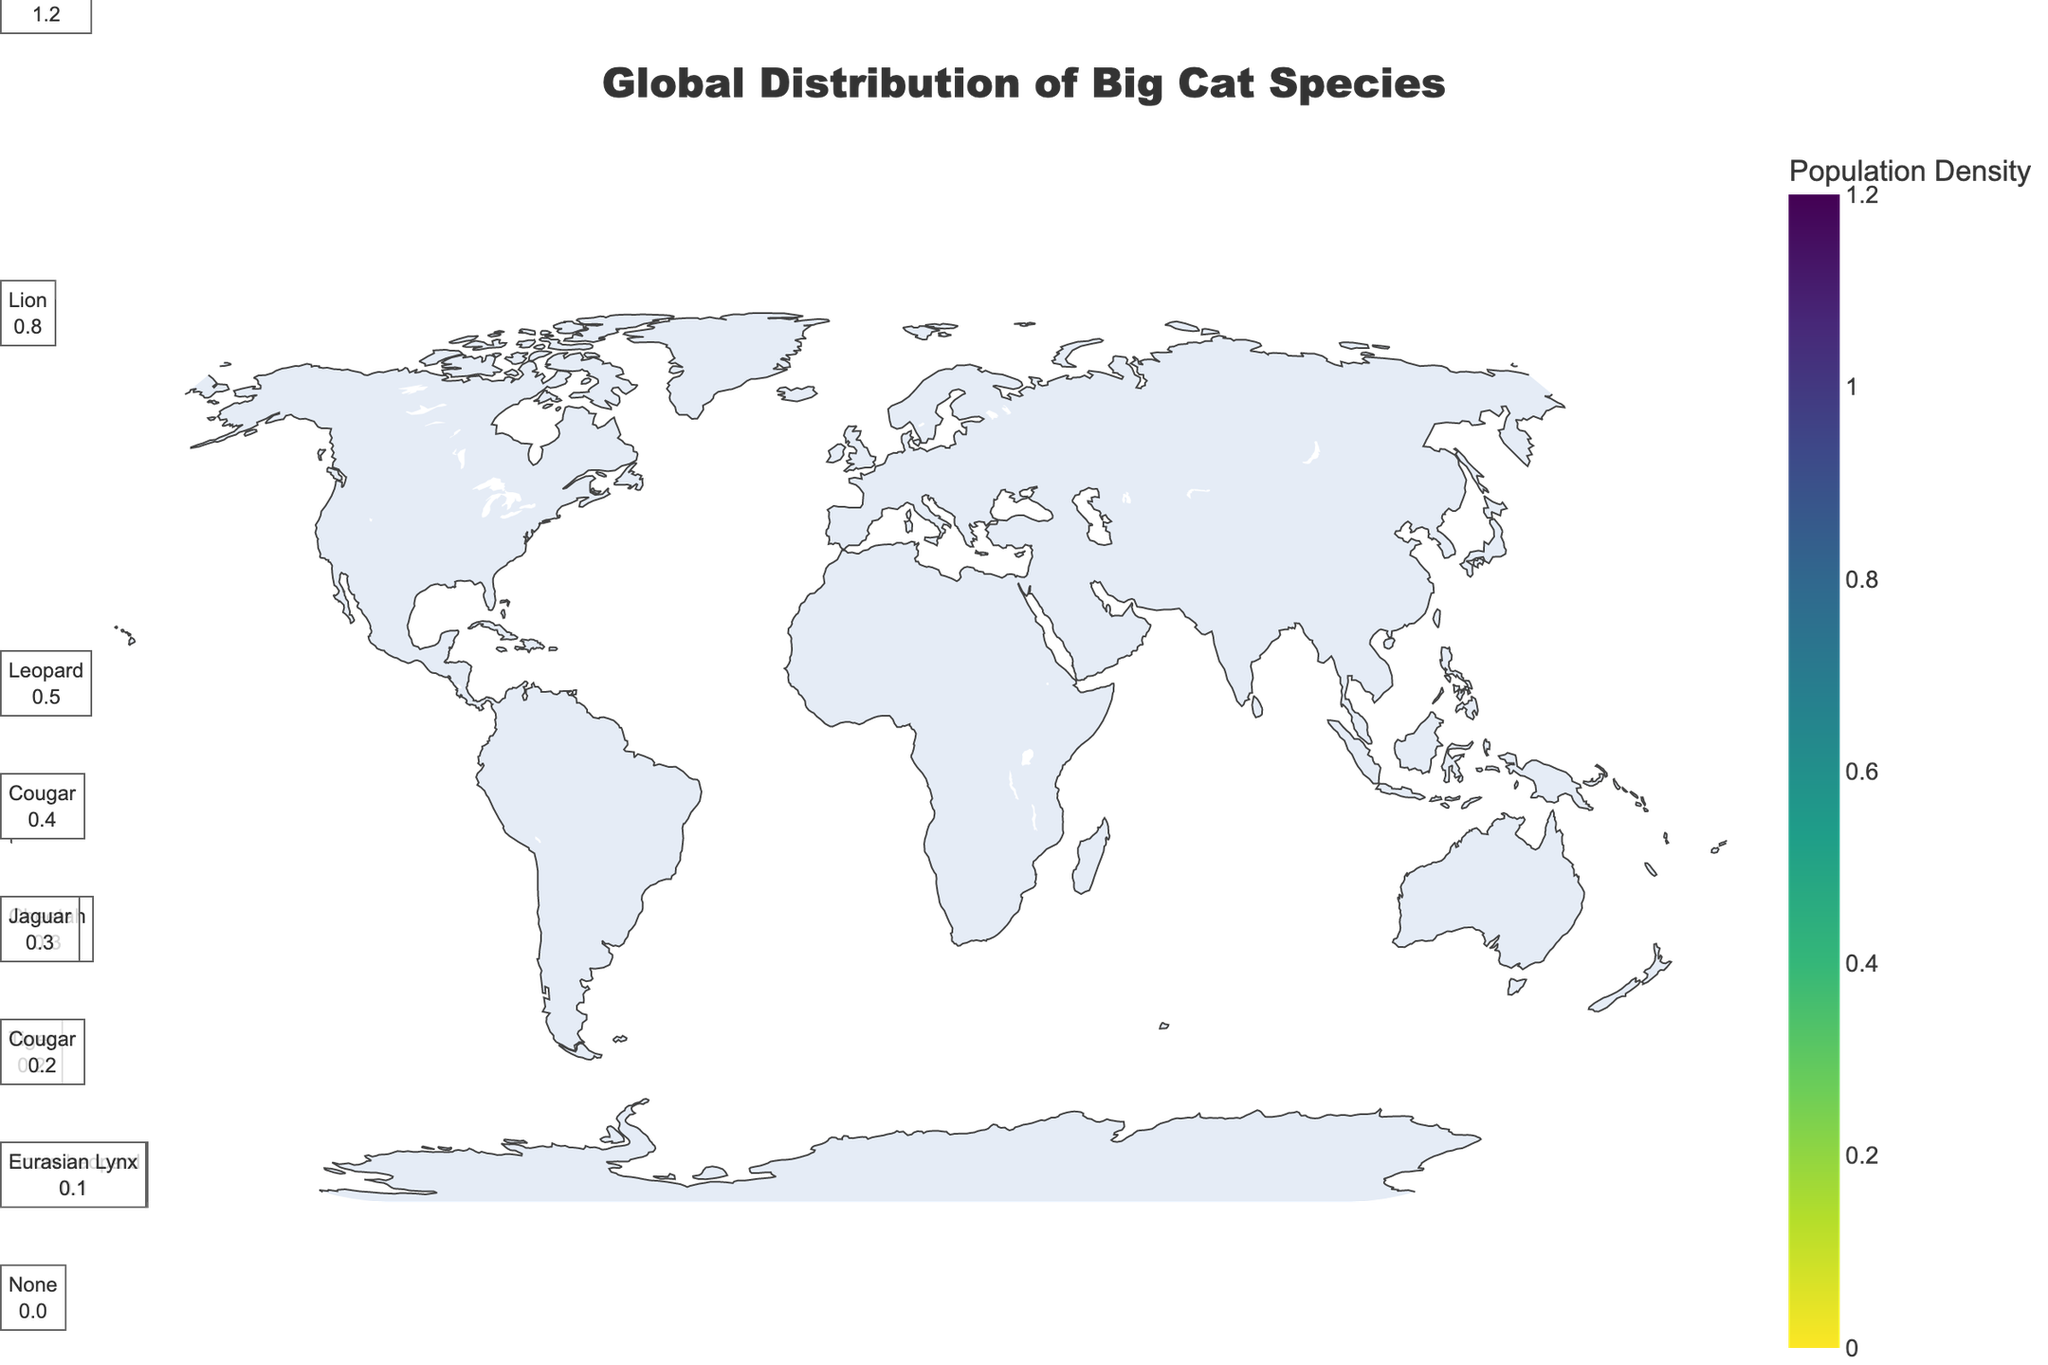Which region has the highest population density of big cats? By looking at the color intensity and the population density values, it is evident that Africa has the highest population density with values such as 1.2 (Leopard) and 0.8 (Lion).
Answer: Africa Which species has the highest population density in Africa? From the annotations and color intensities in Africa, we can see that the Leopard has the highest population density with a value of 1.2.
Answer: Leopard How does the population density of Lions in Africa compare to the population density of Cougars in South America? The population density of Lions in Africa is 0.8, whereas the population density of Cougars in South America is 0.2. Therefore, Lions in Africa have a higher population density than Cougars in South America.
Answer: Lions in Africa have a higher population density Which continent has no big cat species present? By observing the regions and the corresponding population densities, Oceania has a population density of 0 and the annotation also confirms that no species are present.
Answer: Oceania What is the total population density of big cats in Asia? Adding up the values for Asia: Tiger (0.2), Leopard (0.5), and Snow Leopard (0.1), we get a total population density of 0.8.
Answer: 0.8 Are there any regions with equal population densities of big cat species? Comparing the values, both the Cougars in North America and South America have a population density of 0.2.
Answer: Yes, Cougars in North America and South America Which big cat species is found in both Africa and Asia? By looking at the species annotations in both Africa and Asia, the Leopard is present in both regions.
Answer: Leopard What is the population density difference between Cheetahs in Africa and Jaguars in South America? The population density of Cheetahs in Africa is 0.3 and that of Jaguars in South America is also 0.3. The difference is 0.3 - 0.3 = 0.
Answer: 0 How does the population density of Snow Leopards in Asia compare to Eurasian Lynx in Europe? The population density of Snow Leopards in Asia is 0.1, which is equal to the population density of Eurasian Lynx in Europe, also 0.1.
Answer: They are equal 